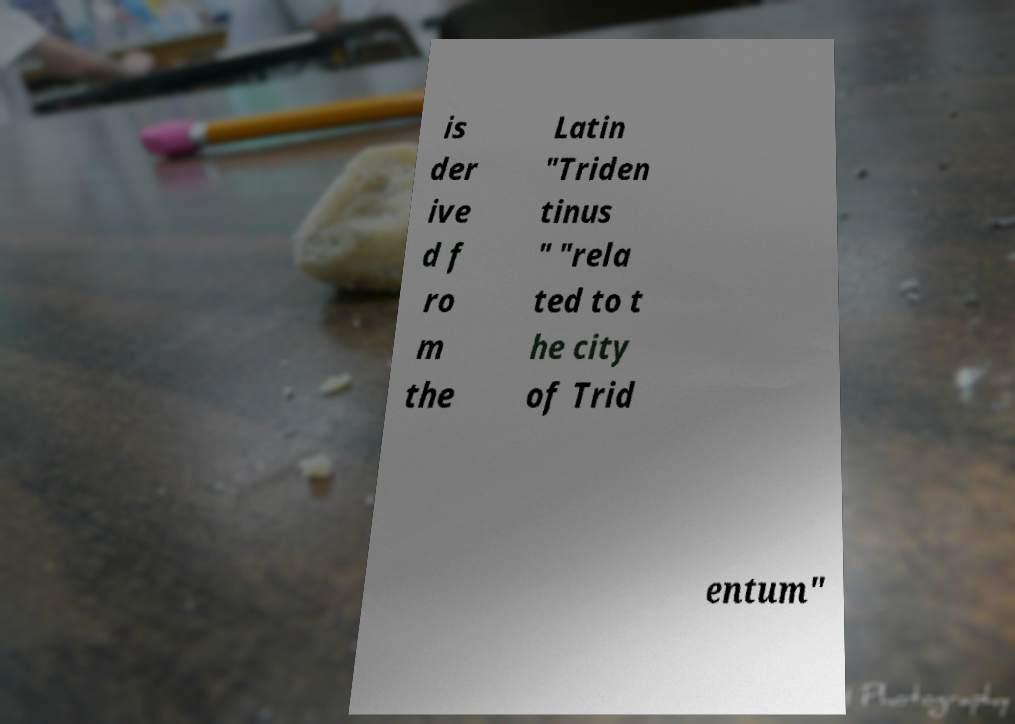I need the written content from this picture converted into text. Can you do that? is der ive d f ro m the Latin "Triden tinus " "rela ted to t he city of Trid entum" 